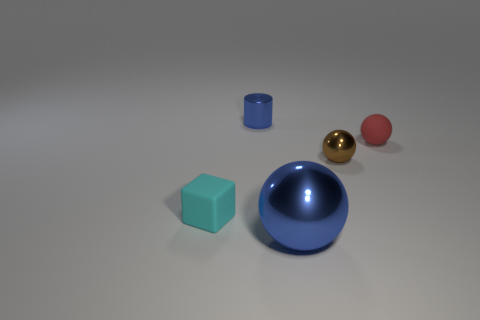Add 1 cylinders. How many objects exist? 6 Subtract all spheres. How many objects are left? 2 Subtract all tiny brown cubes. Subtract all large blue shiny objects. How many objects are left? 4 Add 5 red objects. How many red objects are left? 6 Add 2 small red spheres. How many small red spheres exist? 3 Subtract 0 purple spheres. How many objects are left? 5 